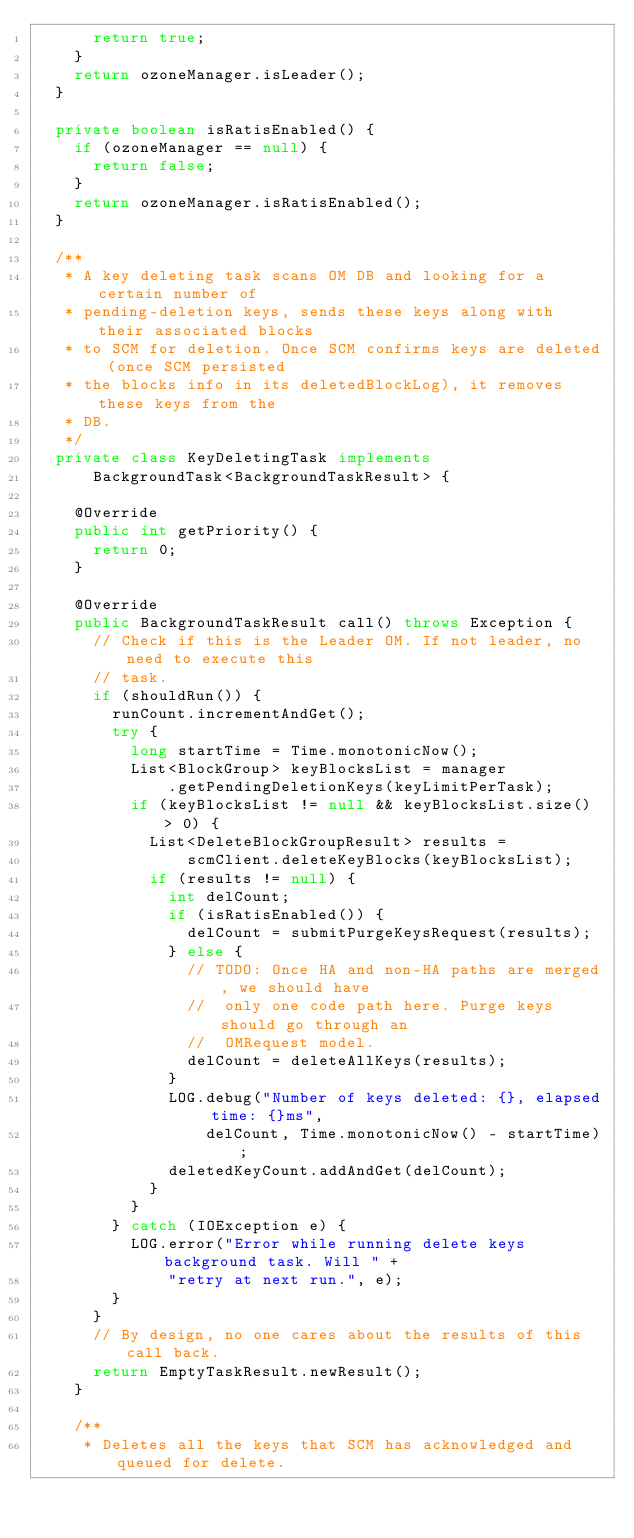Convert code to text. <code><loc_0><loc_0><loc_500><loc_500><_Java_>      return true;
    }
    return ozoneManager.isLeader();
  }

  private boolean isRatisEnabled() {
    if (ozoneManager == null) {
      return false;
    }
    return ozoneManager.isRatisEnabled();
  }

  /**
   * A key deleting task scans OM DB and looking for a certain number of
   * pending-deletion keys, sends these keys along with their associated blocks
   * to SCM for deletion. Once SCM confirms keys are deleted (once SCM persisted
   * the blocks info in its deletedBlockLog), it removes these keys from the
   * DB.
   */
  private class KeyDeletingTask implements
      BackgroundTask<BackgroundTaskResult> {

    @Override
    public int getPriority() {
      return 0;
    }

    @Override
    public BackgroundTaskResult call() throws Exception {
      // Check if this is the Leader OM. If not leader, no need to execute this
      // task.
      if (shouldRun()) {
        runCount.incrementAndGet();
        try {
          long startTime = Time.monotonicNow();
          List<BlockGroup> keyBlocksList = manager
              .getPendingDeletionKeys(keyLimitPerTask);
          if (keyBlocksList != null && keyBlocksList.size() > 0) {
            List<DeleteBlockGroupResult> results =
                scmClient.deleteKeyBlocks(keyBlocksList);
            if (results != null) {
              int delCount;
              if (isRatisEnabled()) {
                delCount = submitPurgeKeysRequest(results);
              } else {
                // TODO: Once HA and non-HA paths are merged, we should have
                //  only one code path here. Purge keys should go through an
                //  OMRequest model.
                delCount = deleteAllKeys(results);
              }
              LOG.debug("Number of keys deleted: {}, elapsed time: {}ms",
                  delCount, Time.monotonicNow() - startTime);
              deletedKeyCount.addAndGet(delCount);
            }
          }
        } catch (IOException e) {
          LOG.error("Error while running delete keys background task. Will " +
              "retry at next run.", e);
        }
      }
      // By design, no one cares about the results of this call back.
      return EmptyTaskResult.newResult();
    }

    /**
     * Deletes all the keys that SCM has acknowledged and queued for delete.</code> 